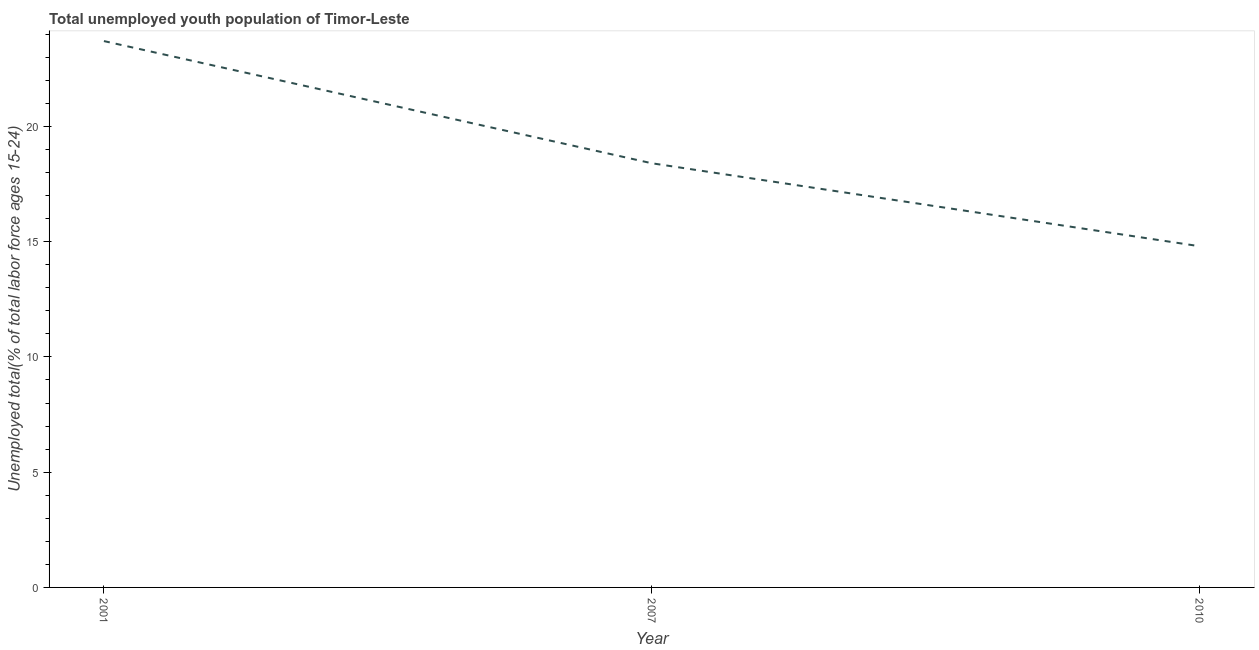What is the unemployed youth in 2010?
Ensure brevity in your answer.  14.8. Across all years, what is the maximum unemployed youth?
Offer a terse response. 23.7. Across all years, what is the minimum unemployed youth?
Offer a terse response. 14.8. In which year was the unemployed youth maximum?
Offer a very short reply. 2001. In which year was the unemployed youth minimum?
Provide a succinct answer. 2010. What is the sum of the unemployed youth?
Provide a short and direct response. 56.9. What is the difference between the unemployed youth in 2001 and 2010?
Keep it short and to the point. 8.9. What is the average unemployed youth per year?
Ensure brevity in your answer.  18.97. What is the median unemployed youth?
Offer a terse response. 18.4. Do a majority of the years between 2010 and 2007 (inclusive) have unemployed youth greater than 3 %?
Make the answer very short. No. What is the ratio of the unemployed youth in 2007 to that in 2010?
Provide a short and direct response. 1.24. Is the unemployed youth in 2001 less than that in 2007?
Your answer should be very brief. No. Is the difference between the unemployed youth in 2001 and 2010 greater than the difference between any two years?
Provide a succinct answer. Yes. What is the difference between the highest and the second highest unemployed youth?
Your answer should be very brief. 5.3. Is the sum of the unemployed youth in 2007 and 2010 greater than the maximum unemployed youth across all years?
Offer a terse response. Yes. What is the difference between the highest and the lowest unemployed youth?
Your response must be concise. 8.9. In how many years, is the unemployed youth greater than the average unemployed youth taken over all years?
Provide a short and direct response. 1. How many years are there in the graph?
Ensure brevity in your answer.  3. Are the values on the major ticks of Y-axis written in scientific E-notation?
Your answer should be very brief. No. What is the title of the graph?
Ensure brevity in your answer.  Total unemployed youth population of Timor-Leste. What is the label or title of the Y-axis?
Give a very brief answer. Unemployed total(% of total labor force ages 15-24). What is the Unemployed total(% of total labor force ages 15-24) of 2001?
Give a very brief answer. 23.7. What is the Unemployed total(% of total labor force ages 15-24) in 2007?
Provide a short and direct response. 18.4. What is the Unemployed total(% of total labor force ages 15-24) of 2010?
Give a very brief answer. 14.8. What is the difference between the Unemployed total(% of total labor force ages 15-24) in 2001 and 2007?
Your answer should be compact. 5.3. What is the ratio of the Unemployed total(% of total labor force ages 15-24) in 2001 to that in 2007?
Offer a terse response. 1.29. What is the ratio of the Unemployed total(% of total labor force ages 15-24) in 2001 to that in 2010?
Provide a succinct answer. 1.6. What is the ratio of the Unemployed total(% of total labor force ages 15-24) in 2007 to that in 2010?
Provide a short and direct response. 1.24. 